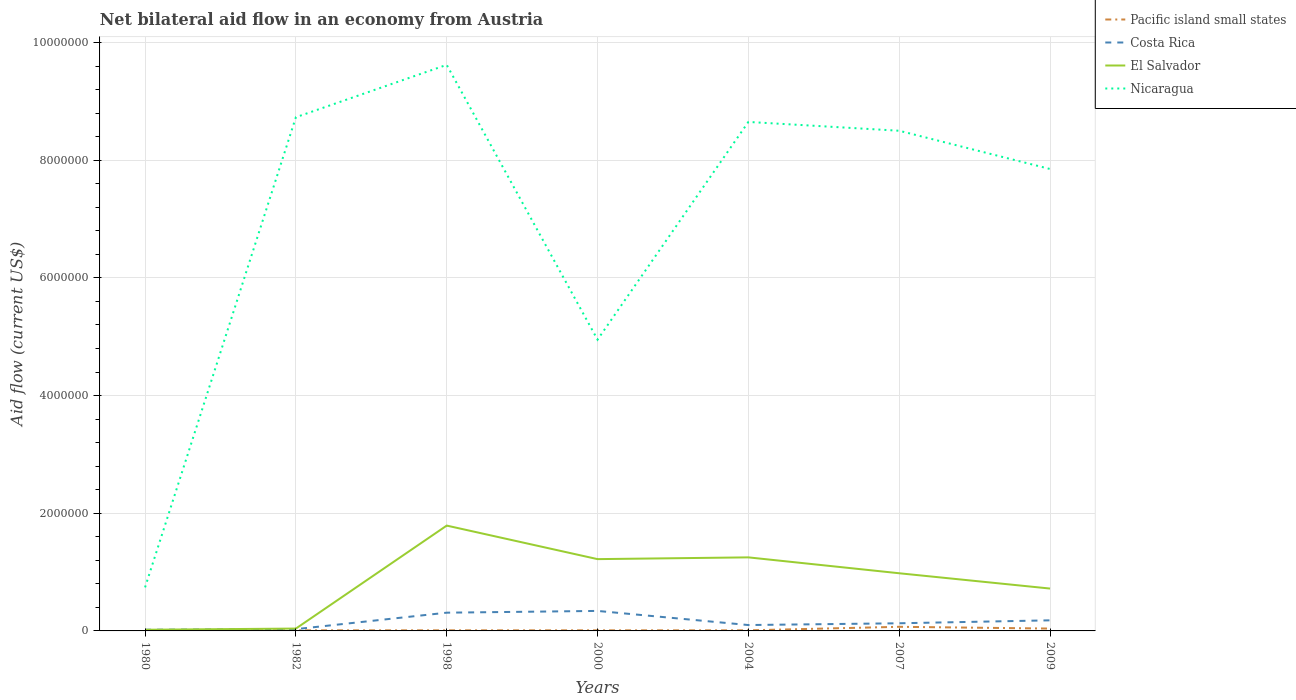Does the line corresponding to Nicaragua intersect with the line corresponding to El Salvador?
Offer a very short reply. No. Is the number of lines equal to the number of legend labels?
Ensure brevity in your answer.  Yes. What is the difference between the highest and the second highest net bilateral aid flow in Nicaragua?
Provide a short and direct response. 8.88e+06. How many lines are there?
Offer a terse response. 4. What is the difference between two consecutive major ticks on the Y-axis?
Your answer should be compact. 2.00e+06. Does the graph contain grids?
Keep it short and to the point. Yes. Where does the legend appear in the graph?
Provide a succinct answer. Top right. What is the title of the graph?
Your answer should be compact. Net bilateral aid flow in an economy from Austria. What is the label or title of the X-axis?
Offer a very short reply. Years. What is the label or title of the Y-axis?
Offer a very short reply. Aid flow (current US$). What is the Aid flow (current US$) in Pacific island small states in 1980?
Provide a short and direct response. 10000. What is the Aid flow (current US$) in Nicaragua in 1980?
Your answer should be very brief. 7.40e+05. What is the Aid flow (current US$) in Pacific island small states in 1982?
Keep it short and to the point. 10000. What is the Aid flow (current US$) of El Salvador in 1982?
Your answer should be compact. 4.00e+04. What is the Aid flow (current US$) of Nicaragua in 1982?
Provide a short and direct response. 8.73e+06. What is the Aid flow (current US$) in Costa Rica in 1998?
Give a very brief answer. 3.10e+05. What is the Aid flow (current US$) in El Salvador in 1998?
Offer a terse response. 1.79e+06. What is the Aid flow (current US$) of Nicaragua in 1998?
Give a very brief answer. 9.62e+06. What is the Aid flow (current US$) in Costa Rica in 2000?
Keep it short and to the point. 3.40e+05. What is the Aid flow (current US$) of El Salvador in 2000?
Give a very brief answer. 1.22e+06. What is the Aid flow (current US$) of Nicaragua in 2000?
Give a very brief answer. 4.95e+06. What is the Aid flow (current US$) in Pacific island small states in 2004?
Keep it short and to the point. 10000. What is the Aid flow (current US$) of El Salvador in 2004?
Your answer should be compact. 1.25e+06. What is the Aid flow (current US$) in Nicaragua in 2004?
Keep it short and to the point. 8.65e+06. What is the Aid flow (current US$) in El Salvador in 2007?
Provide a succinct answer. 9.80e+05. What is the Aid flow (current US$) in Nicaragua in 2007?
Make the answer very short. 8.50e+06. What is the Aid flow (current US$) of El Salvador in 2009?
Provide a succinct answer. 7.20e+05. What is the Aid flow (current US$) of Nicaragua in 2009?
Your response must be concise. 7.85e+06. Across all years, what is the maximum Aid flow (current US$) in El Salvador?
Offer a terse response. 1.79e+06. Across all years, what is the maximum Aid flow (current US$) of Nicaragua?
Your answer should be compact. 9.62e+06. Across all years, what is the minimum Aid flow (current US$) in Costa Rica?
Give a very brief answer. 2.00e+04. Across all years, what is the minimum Aid flow (current US$) of Nicaragua?
Ensure brevity in your answer.  7.40e+05. What is the total Aid flow (current US$) of Costa Rica in the graph?
Offer a very short reply. 1.11e+06. What is the total Aid flow (current US$) of El Salvador in the graph?
Your answer should be very brief. 6.02e+06. What is the total Aid flow (current US$) of Nicaragua in the graph?
Your answer should be compact. 4.90e+07. What is the difference between the Aid flow (current US$) in El Salvador in 1980 and that in 1982?
Your answer should be compact. -2.00e+04. What is the difference between the Aid flow (current US$) in Nicaragua in 1980 and that in 1982?
Your response must be concise. -7.99e+06. What is the difference between the Aid flow (current US$) of El Salvador in 1980 and that in 1998?
Offer a very short reply. -1.77e+06. What is the difference between the Aid flow (current US$) of Nicaragua in 1980 and that in 1998?
Your response must be concise. -8.88e+06. What is the difference between the Aid flow (current US$) in Pacific island small states in 1980 and that in 2000?
Your response must be concise. 0. What is the difference between the Aid flow (current US$) of Costa Rica in 1980 and that in 2000?
Provide a succinct answer. -3.20e+05. What is the difference between the Aid flow (current US$) in El Salvador in 1980 and that in 2000?
Ensure brevity in your answer.  -1.20e+06. What is the difference between the Aid flow (current US$) in Nicaragua in 1980 and that in 2000?
Ensure brevity in your answer.  -4.21e+06. What is the difference between the Aid flow (current US$) in Pacific island small states in 1980 and that in 2004?
Make the answer very short. 0. What is the difference between the Aid flow (current US$) in El Salvador in 1980 and that in 2004?
Provide a succinct answer. -1.23e+06. What is the difference between the Aid flow (current US$) in Nicaragua in 1980 and that in 2004?
Your answer should be very brief. -7.91e+06. What is the difference between the Aid flow (current US$) in El Salvador in 1980 and that in 2007?
Provide a succinct answer. -9.60e+05. What is the difference between the Aid flow (current US$) of Nicaragua in 1980 and that in 2007?
Your response must be concise. -7.76e+06. What is the difference between the Aid flow (current US$) of Pacific island small states in 1980 and that in 2009?
Keep it short and to the point. -3.00e+04. What is the difference between the Aid flow (current US$) of Costa Rica in 1980 and that in 2009?
Provide a short and direct response. -1.60e+05. What is the difference between the Aid flow (current US$) in El Salvador in 1980 and that in 2009?
Ensure brevity in your answer.  -7.00e+05. What is the difference between the Aid flow (current US$) in Nicaragua in 1980 and that in 2009?
Offer a terse response. -7.11e+06. What is the difference between the Aid flow (current US$) of Pacific island small states in 1982 and that in 1998?
Provide a succinct answer. 0. What is the difference between the Aid flow (current US$) of Costa Rica in 1982 and that in 1998?
Give a very brief answer. -2.80e+05. What is the difference between the Aid flow (current US$) of El Salvador in 1982 and that in 1998?
Offer a very short reply. -1.75e+06. What is the difference between the Aid flow (current US$) of Nicaragua in 1982 and that in 1998?
Provide a short and direct response. -8.90e+05. What is the difference between the Aid flow (current US$) of Pacific island small states in 1982 and that in 2000?
Your answer should be compact. 0. What is the difference between the Aid flow (current US$) of Costa Rica in 1982 and that in 2000?
Your answer should be compact. -3.10e+05. What is the difference between the Aid flow (current US$) in El Salvador in 1982 and that in 2000?
Provide a succinct answer. -1.18e+06. What is the difference between the Aid flow (current US$) in Nicaragua in 1982 and that in 2000?
Your answer should be very brief. 3.78e+06. What is the difference between the Aid flow (current US$) in Pacific island small states in 1982 and that in 2004?
Your answer should be very brief. 0. What is the difference between the Aid flow (current US$) in Costa Rica in 1982 and that in 2004?
Provide a succinct answer. -7.00e+04. What is the difference between the Aid flow (current US$) in El Salvador in 1982 and that in 2004?
Your answer should be compact. -1.21e+06. What is the difference between the Aid flow (current US$) in Nicaragua in 1982 and that in 2004?
Provide a succinct answer. 8.00e+04. What is the difference between the Aid flow (current US$) of El Salvador in 1982 and that in 2007?
Ensure brevity in your answer.  -9.40e+05. What is the difference between the Aid flow (current US$) in El Salvador in 1982 and that in 2009?
Offer a terse response. -6.80e+05. What is the difference between the Aid flow (current US$) in Nicaragua in 1982 and that in 2009?
Ensure brevity in your answer.  8.80e+05. What is the difference between the Aid flow (current US$) in Pacific island small states in 1998 and that in 2000?
Your response must be concise. 0. What is the difference between the Aid flow (current US$) in El Salvador in 1998 and that in 2000?
Your response must be concise. 5.70e+05. What is the difference between the Aid flow (current US$) of Nicaragua in 1998 and that in 2000?
Provide a succinct answer. 4.67e+06. What is the difference between the Aid flow (current US$) in Pacific island small states in 1998 and that in 2004?
Offer a terse response. 0. What is the difference between the Aid flow (current US$) of El Salvador in 1998 and that in 2004?
Offer a very short reply. 5.40e+05. What is the difference between the Aid flow (current US$) of Nicaragua in 1998 and that in 2004?
Your response must be concise. 9.70e+05. What is the difference between the Aid flow (current US$) of Costa Rica in 1998 and that in 2007?
Provide a short and direct response. 1.80e+05. What is the difference between the Aid flow (current US$) in El Salvador in 1998 and that in 2007?
Make the answer very short. 8.10e+05. What is the difference between the Aid flow (current US$) in Nicaragua in 1998 and that in 2007?
Provide a short and direct response. 1.12e+06. What is the difference between the Aid flow (current US$) in Pacific island small states in 1998 and that in 2009?
Your response must be concise. -3.00e+04. What is the difference between the Aid flow (current US$) in Costa Rica in 1998 and that in 2009?
Your response must be concise. 1.30e+05. What is the difference between the Aid flow (current US$) of El Salvador in 1998 and that in 2009?
Ensure brevity in your answer.  1.07e+06. What is the difference between the Aid flow (current US$) of Nicaragua in 1998 and that in 2009?
Ensure brevity in your answer.  1.77e+06. What is the difference between the Aid flow (current US$) of Costa Rica in 2000 and that in 2004?
Your answer should be very brief. 2.40e+05. What is the difference between the Aid flow (current US$) of Nicaragua in 2000 and that in 2004?
Make the answer very short. -3.70e+06. What is the difference between the Aid flow (current US$) in El Salvador in 2000 and that in 2007?
Offer a very short reply. 2.40e+05. What is the difference between the Aid flow (current US$) of Nicaragua in 2000 and that in 2007?
Provide a short and direct response. -3.55e+06. What is the difference between the Aid flow (current US$) in Pacific island small states in 2000 and that in 2009?
Your response must be concise. -3.00e+04. What is the difference between the Aid flow (current US$) in Costa Rica in 2000 and that in 2009?
Offer a terse response. 1.60e+05. What is the difference between the Aid flow (current US$) of El Salvador in 2000 and that in 2009?
Offer a very short reply. 5.00e+05. What is the difference between the Aid flow (current US$) of Nicaragua in 2000 and that in 2009?
Provide a succinct answer. -2.90e+06. What is the difference between the Aid flow (current US$) of Costa Rica in 2004 and that in 2007?
Offer a very short reply. -3.00e+04. What is the difference between the Aid flow (current US$) of Nicaragua in 2004 and that in 2007?
Your answer should be very brief. 1.50e+05. What is the difference between the Aid flow (current US$) in Costa Rica in 2004 and that in 2009?
Your answer should be very brief. -8.00e+04. What is the difference between the Aid flow (current US$) of El Salvador in 2004 and that in 2009?
Keep it short and to the point. 5.30e+05. What is the difference between the Aid flow (current US$) in Nicaragua in 2004 and that in 2009?
Give a very brief answer. 8.00e+05. What is the difference between the Aid flow (current US$) in Pacific island small states in 2007 and that in 2009?
Give a very brief answer. 3.00e+04. What is the difference between the Aid flow (current US$) in Nicaragua in 2007 and that in 2009?
Make the answer very short. 6.50e+05. What is the difference between the Aid flow (current US$) in Pacific island small states in 1980 and the Aid flow (current US$) in Costa Rica in 1982?
Keep it short and to the point. -2.00e+04. What is the difference between the Aid flow (current US$) of Pacific island small states in 1980 and the Aid flow (current US$) of El Salvador in 1982?
Offer a very short reply. -3.00e+04. What is the difference between the Aid flow (current US$) in Pacific island small states in 1980 and the Aid flow (current US$) in Nicaragua in 1982?
Keep it short and to the point. -8.72e+06. What is the difference between the Aid flow (current US$) of Costa Rica in 1980 and the Aid flow (current US$) of El Salvador in 1982?
Your answer should be compact. -2.00e+04. What is the difference between the Aid flow (current US$) of Costa Rica in 1980 and the Aid flow (current US$) of Nicaragua in 1982?
Ensure brevity in your answer.  -8.71e+06. What is the difference between the Aid flow (current US$) in El Salvador in 1980 and the Aid flow (current US$) in Nicaragua in 1982?
Provide a succinct answer. -8.71e+06. What is the difference between the Aid flow (current US$) in Pacific island small states in 1980 and the Aid flow (current US$) in Costa Rica in 1998?
Offer a terse response. -3.00e+05. What is the difference between the Aid flow (current US$) in Pacific island small states in 1980 and the Aid flow (current US$) in El Salvador in 1998?
Provide a succinct answer. -1.78e+06. What is the difference between the Aid flow (current US$) in Pacific island small states in 1980 and the Aid flow (current US$) in Nicaragua in 1998?
Your response must be concise. -9.61e+06. What is the difference between the Aid flow (current US$) in Costa Rica in 1980 and the Aid flow (current US$) in El Salvador in 1998?
Offer a very short reply. -1.77e+06. What is the difference between the Aid flow (current US$) of Costa Rica in 1980 and the Aid flow (current US$) of Nicaragua in 1998?
Keep it short and to the point. -9.60e+06. What is the difference between the Aid flow (current US$) of El Salvador in 1980 and the Aid flow (current US$) of Nicaragua in 1998?
Make the answer very short. -9.60e+06. What is the difference between the Aid flow (current US$) in Pacific island small states in 1980 and the Aid flow (current US$) in Costa Rica in 2000?
Make the answer very short. -3.30e+05. What is the difference between the Aid flow (current US$) of Pacific island small states in 1980 and the Aid flow (current US$) of El Salvador in 2000?
Make the answer very short. -1.21e+06. What is the difference between the Aid flow (current US$) in Pacific island small states in 1980 and the Aid flow (current US$) in Nicaragua in 2000?
Your response must be concise. -4.94e+06. What is the difference between the Aid flow (current US$) of Costa Rica in 1980 and the Aid flow (current US$) of El Salvador in 2000?
Keep it short and to the point. -1.20e+06. What is the difference between the Aid flow (current US$) in Costa Rica in 1980 and the Aid flow (current US$) in Nicaragua in 2000?
Your response must be concise. -4.93e+06. What is the difference between the Aid flow (current US$) of El Salvador in 1980 and the Aid flow (current US$) of Nicaragua in 2000?
Ensure brevity in your answer.  -4.93e+06. What is the difference between the Aid flow (current US$) of Pacific island small states in 1980 and the Aid flow (current US$) of El Salvador in 2004?
Keep it short and to the point. -1.24e+06. What is the difference between the Aid flow (current US$) of Pacific island small states in 1980 and the Aid flow (current US$) of Nicaragua in 2004?
Provide a short and direct response. -8.64e+06. What is the difference between the Aid flow (current US$) of Costa Rica in 1980 and the Aid flow (current US$) of El Salvador in 2004?
Make the answer very short. -1.23e+06. What is the difference between the Aid flow (current US$) of Costa Rica in 1980 and the Aid flow (current US$) of Nicaragua in 2004?
Ensure brevity in your answer.  -8.63e+06. What is the difference between the Aid flow (current US$) of El Salvador in 1980 and the Aid flow (current US$) of Nicaragua in 2004?
Ensure brevity in your answer.  -8.63e+06. What is the difference between the Aid flow (current US$) in Pacific island small states in 1980 and the Aid flow (current US$) in Costa Rica in 2007?
Keep it short and to the point. -1.20e+05. What is the difference between the Aid flow (current US$) of Pacific island small states in 1980 and the Aid flow (current US$) of El Salvador in 2007?
Make the answer very short. -9.70e+05. What is the difference between the Aid flow (current US$) in Pacific island small states in 1980 and the Aid flow (current US$) in Nicaragua in 2007?
Keep it short and to the point. -8.49e+06. What is the difference between the Aid flow (current US$) in Costa Rica in 1980 and the Aid flow (current US$) in El Salvador in 2007?
Give a very brief answer. -9.60e+05. What is the difference between the Aid flow (current US$) of Costa Rica in 1980 and the Aid flow (current US$) of Nicaragua in 2007?
Offer a very short reply. -8.48e+06. What is the difference between the Aid flow (current US$) of El Salvador in 1980 and the Aid flow (current US$) of Nicaragua in 2007?
Offer a terse response. -8.48e+06. What is the difference between the Aid flow (current US$) in Pacific island small states in 1980 and the Aid flow (current US$) in El Salvador in 2009?
Make the answer very short. -7.10e+05. What is the difference between the Aid flow (current US$) in Pacific island small states in 1980 and the Aid flow (current US$) in Nicaragua in 2009?
Offer a terse response. -7.84e+06. What is the difference between the Aid flow (current US$) in Costa Rica in 1980 and the Aid flow (current US$) in El Salvador in 2009?
Keep it short and to the point. -7.00e+05. What is the difference between the Aid flow (current US$) in Costa Rica in 1980 and the Aid flow (current US$) in Nicaragua in 2009?
Provide a succinct answer. -7.83e+06. What is the difference between the Aid flow (current US$) in El Salvador in 1980 and the Aid flow (current US$) in Nicaragua in 2009?
Offer a terse response. -7.83e+06. What is the difference between the Aid flow (current US$) of Pacific island small states in 1982 and the Aid flow (current US$) of Costa Rica in 1998?
Make the answer very short. -3.00e+05. What is the difference between the Aid flow (current US$) in Pacific island small states in 1982 and the Aid flow (current US$) in El Salvador in 1998?
Your answer should be very brief. -1.78e+06. What is the difference between the Aid flow (current US$) of Pacific island small states in 1982 and the Aid flow (current US$) of Nicaragua in 1998?
Your answer should be compact. -9.61e+06. What is the difference between the Aid flow (current US$) in Costa Rica in 1982 and the Aid flow (current US$) in El Salvador in 1998?
Ensure brevity in your answer.  -1.76e+06. What is the difference between the Aid flow (current US$) in Costa Rica in 1982 and the Aid flow (current US$) in Nicaragua in 1998?
Your response must be concise. -9.59e+06. What is the difference between the Aid flow (current US$) in El Salvador in 1982 and the Aid flow (current US$) in Nicaragua in 1998?
Offer a terse response. -9.58e+06. What is the difference between the Aid flow (current US$) of Pacific island small states in 1982 and the Aid flow (current US$) of Costa Rica in 2000?
Your answer should be very brief. -3.30e+05. What is the difference between the Aid flow (current US$) of Pacific island small states in 1982 and the Aid flow (current US$) of El Salvador in 2000?
Keep it short and to the point. -1.21e+06. What is the difference between the Aid flow (current US$) in Pacific island small states in 1982 and the Aid flow (current US$) in Nicaragua in 2000?
Your response must be concise. -4.94e+06. What is the difference between the Aid flow (current US$) of Costa Rica in 1982 and the Aid flow (current US$) of El Salvador in 2000?
Your response must be concise. -1.19e+06. What is the difference between the Aid flow (current US$) of Costa Rica in 1982 and the Aid flow (current US$) of Nicaragua in 2000?
Offer a terse response. -4.92e+06. What is the difference between the Aid flow (current US$) in El Salvador in 1982 and the Aid flow (current US$) in Nicaragua in 2000?
Make the answer very short. -4.91e+06. What is the difference between the Aid flow (current US$) of Pacific island small states in 1982 and the Aid flow (current US$) of El Salvador in 2004?
Offer a terse response. -1.24e+06. What is the difference between the Aid flow (current US$) in Pacific island small states in 1982 and the Aid flow (current US$) in Nicaragua in 2004?
Your answer should be very brief. -8.64e+06. What is the difference between the Aid flow (current US$) of Costa Rica in 1982 and the Aid flow (current US$) of El Salvador in 2004?
Offer a terse response. -1.22e+06. What is the difference between the Aid flow (current US$) in Costa Rica in 1982 and the Aid flow (current US$) in Nicaragua in 2004?
Provide a short and direct response. -8.62e+06. What is the difference between the Aid flow (current US$) of El Salvador in 1982 and the Aid flow (current US$) of Nicaragua in 2004?
Ensure brevity in your answer.  -8.61e+06. What is the difference between the Aid flow (current US$) of Pacific island small states in 1982 and the Aid flow (current US$) of El Salvador in 2007?
Your response must be concise. -9.70e+05. What is the difference between the Aid flow (current US$) in Pacific island small states in 1982 and the Aid flow (current US$) in Nicaragua in 2007?
Your response must be concise. -8.49e+06. What is the difference between the Aid flow (current US$) in Costa Rica in 1982 and the Aid flow (current US$) in El Salvador in 2007?
Offer a very short reply. -9.50e+05. What is the difference between the Aid flow (current US$) of Costa Rica in 1982 and the Aid flow (current US$) of Nicaragua in 2007?
Provide a short and direct response. -8.47e+06. What is the difference between the Aid flow (current US$) of El Salvador in 1982 and the Aid flow (current US$) of Nicaragua in 2007?
Your response must be concise. -8.46e+06. What is the difference between the Aid flow (current US$) in Pacific island small states in 1982 and the Aid flow (current US$) in Costa Rica in 2009?
Offer a very short reply. -1.70e+05. What is the difference between the Aid flow (current US$) in Pacific island small states in 1982 and the Aid flow (current US$) in El Salvador in 2009?
Provide a succinct answer. -7.10e+05. What is the difference between the Aid flow (current US$) of Pacific island small states in 1982 and the Aid flow (current US$) of Nicaragua in 2009?
Offer a very short reply. -7.84e+06. What is the difference between the Aid flow (current US$) in Costa Rica in 1982 and the Aid flow (current US$) in El Salvador in 2009?
Make the answer very short. -6.90e+05. What is the difference between the Aid flow (current US$) in Costa Rica in 1982 and the Aid flow (current US$) in Nicaragua in 2009?
Offer a terse response. -7.82e+06. What is the difference between the Aid flow (current US$) in El Salvador in 1982 and the Aid flow (current US$) in Nicaragua in 2009?
Give a very brief answer. -7.81e+06. What is the difference between the Aid flow (current US$) in Pacific island small states in 1998 and the Aid flow (current US$) in Costa Rica in 2000?
Provide a succinct answer. -3.30e+05. What is the difference between the Aid flow (current US$) in Pacific island small states in 1998 and the Aid flow (current US$) in El Salvador in 2000?
Give a very brief answer. -1.21e+06. What is the difference between the Aid flow (current US$) of Pacific island small states in 1998 and the Aid flow (current US$) of Nicaragua in 2000?
Ensure brevity in your answer.  -4.94e+06. What is the difference between the Aid flow (current US$) of Costa Rica in 1998 and the Aid flow (current US$) of El Salvador in 2000?
Provide a succinct answer. -9.10e+05. What is the difference between the Aid flow (current US$) of Costa Rica in 1998 and the Aid flow (current US$) of Nicaragua in 2000?
Provide a succinct answer. -4.64e+06. What is the difference between the Aid flow (current US$) in El Salvador in 1998 and the Aid flow (current US$) in Nicaragua in 2000?
Make the answer very short. -3.16e+06. What is the difference between the Aid flow (current US$) in Pacific island small states in 1998 and the Aid flow (current US$) in Costa Rica in 2004?
Your response must be concise. -9.00e+04. What is the difference between the Aid flow (current US$) in Pacific island small states in 1998 and the Aid flow (current US$) in El Salvador in 2004?
Ensure brevity in your answer.  -1.24e+06. What is the difference between the Aid flow (current US$) in Pacific island small states in 1998 and the Aid flow (current US$) in Nicaragua in 2004?
Offer a terse response. -8.64e+06. What is the difference between the Aid flow (current US$) of Costa Rica in 1998 and the Aid flow (current US$) of El Salvador in 2004?
Provide a short and direct response. -9.40e+05. What is the difference between the Aid flow (current US$) of Costa Rica in 1998 and the Aid flow (current US$) of Nicaragua in 2004?
Your response must be concise. -8.34e+06. What is the difference between the Aid flow (current US$) in El Salvador in 1998 and the Aid flow (current US$) in Nicaragua in 2004?
Keep it short and to the point. -6.86e+06. What is the difference between the Aid flow (current US$) of Pacific island small states in 1998 and the Aid flow (current US$) of El Salvador in 2007?
Your answer should be compact. -9.70e+05. What is the difference between the Aid flow (current US$) of Pacific island small states in 1998 and the Aid flow (current US$) of Nicaragua in 2007?
Provide a short and direct response. -8.49e+06. What is the difference between the Aid flow (current US$) in Costa Rica in 1998 and the Aid flow (current US$) in El Salvador in 2007?
Offer a terse response. -6.70e+05. What is the difference between the Aid flow (current US$) in Costa Rica in 1998 and the Aid flow (current US$) in Nicaragua in 2007?
Provide a succinct answer. -8.19e+06. What is the difference between the Aid flow (current US$) of El Salvador in 1998 and the Aid flow (current US$) of Nicaragua in 2007?
Your answer should be very brief. -6.71e+06. What is the difference between the Aid flow (current US$) of Pacific island small states in 1998 and the Aid flow (current US$) of Costa Rica in 2009?
Your response must be concise. -1.70e+05. What is the difference between the Aid flow (current US$) in Pacific island small states in 1998 and the Aid flow (current US$) in El Salvador in 2009?
Your response must be concise. -7.10e+05. What is the difference between the Aid flow (current US$) in Pacific island small states in 1998 and the Aid flow (current US$) in Nicaragua in 2009?
Provide a short and direct response. -7.84e+06. What is the difference between the Aid flow (current US$) of Costa Rica in 1998 and the Aid flow (current US$) of El Salvador in 2009?
Provide a succinct answer. -4.10e+05. What is the difference between the Aid flow (current US$) in Costa Rica in 1998 and the Aid flow (current US$) in Nicaragua in 2009?
Your answer should be very brief. -7.54e+06. What is the difference between the Aid flow (current US$) of El Salvador in 1998 and the Aid flow (current US$) of Nicaragua in 2009?
Provide a succinct answer. -6.06e+06. What is the difference between the Aid flow (current US$) of Pacific island small states in 2000 and the Aid flow (current US$) of El Salvador in 2004?
Give a very brief answer. -1.24e+06. What is the difference between the Aid flow (current US$) of Pacific island small states in 2000 and the Aid flow (current US$) of Nicaragua in 2004?
Your answer should be very brief. -8.64e+06. What is the difference between the Aid flow (current US$) in Costa Rica in 2000 and the Aid flow (current US$) in El Salvador in 2004?
Make the answer very short. -9.10e+05. What is the difference between the Aid flow (current US$) of Costa Rica in 2000 and the Aid flow (current US$) of Nicaragua in 2004?
Ensure brevity in your answer.  -8.31e+06. What is the difference between the Aid flow (current US$) in El Salvador in 2000 and the Aid flow (current US$) in Nicaragua in 2004?
Ensure brevity in your answer.  -7.43e+06. What is the difference between the Aid flow (current US$) in Pacific island small states in 2000 and the Aid flow (current US$) in El Salvador in 2007?
Make the answer very short. -9.70e+05. What is the difference between the Aid flow (current US$) in Pacific island small states in 2000 and the Aid flow (current US$) in Nicaragua in 2007?
Your answer should be compact. -8.49e+06. What is the difference between the Aid flow (current US$) of Costa Rica in 2000 and the Aid flow (current US$) of El Salvador in 2007?
Make the answer very short. -6.40e+05. What is the difference between the Aid flow (current US$) of Costa Rica in 2000 and the Aid flow (current US$) of Nicaragua in 2007?
Offer a terse response. -8.16e+06. What is the difference between the Aid flow (current US$) of El Salvador in 2000 and the Aid flow (current US$) of Nicaragua in 2007?
Ensure brevity in your answer.  -7.28e+06. What is the difference between the Aid flow (current US$) of Pacific island small states in 2000 and the Aid flow (current US$) of Costa Rica in 2009?
Give a very brief answer. -1.70e+05. What is the difference between the Aid flow (current US$) in Pacific island small states in 2000 and the Aid flow (current US$) in El Salvador in 2009?
Provide a short and direct response. -7.10e+05. What is the difference between the Aid flow (current US$) in Pacific island small states in 2000 and the Aid flow (current US$) in Nicaragua in 2009?
Give a very brief answer. -7.84e+06. What is the difference between the Aid flow (current US$) in Costa Rica in 2000 and the Aid flow (current US$) in El Salvador in 2009?
Your answer should be compact. -3.80e+05. What is the difference between the Aid flow (current US$) of Costa Rica in 2000 and the Aid flow (current US$) of Nicaragua in 2009?
Your answer should be compact. -7.51e+06. What is the difference between the Aid flow (current US$) in El Salvador in 2000 and the Aid flow (current US$) in Nicaragua in 2009?
Your answer should be compact. -6.63e+06. What is the difference between the Aid flow (current US$) of Pacific island small states in 2004 and the Aid flow (current US$) of Costa Rica in 2007?
Your response must be concise. -1.20e+05. What is the difference between the Aid flow (current US$) in Pacific island small states in 2004 and the Aid flow (current US$) in El Salvador in 2007?
Make the answer very short. -9.70e+05. What is the difference between the Aid flow (current US$) of Pacific island small states in 2004 and the Aid flow (current US$) of Nicaragua in 2007?
Provide a short and direct response. -8.49e+06. What is the difference between the Aid flow (current US$) in Costa Rica in 2004 and the Aid flow (current US$) in El Salvador in 2007?
Give a very brief answer. -8.80e+05. What is the difference between the Aid flow (current US$) in Costa Rica in 2004 and the Aid flow (current US$) in Nicaragua in 2007?
Keep it short and to the point. -8.40e+06. What is the difference between the Aid flow (current US$) of El Salvador in 2004 and the Aid flow (current US$) of Nicaragua in 2007?
Provide a succinct answer. -7.25e+06. What is the difference between the Aid flow (current US$) in Pacific island small states in 2004 and the Aid flow (current US$) in El Salvador in 2009?
Provide a succinct answer. -7.10e+05. What is the difference between the Aid flow (current US$) of Pacific island small states in 2004 and the Aid flow (current US$) of Nicaragua in 2009?
Provide a short and direct response. -7.84e+06. What is the difference between the Aid flow (current US$) of Costa Rica in 2004 and the Aid flow (current US$) of El Salvador in 2009?
Your answer should be very brief. -6.20e+05. What is the difference between the Aid flow (current US$) of Costa Rica in 2004 and the Aid flow (current US$) of Nicaragua in 2009?
Your answer should be very brief. -7.75e+06. What is the difference between the Aid flow (current US$) in El Salvador in 2004 and the Aid flow (current US$) in Nicaragua in 2009?
Provide a succinct answer. -6.60e+06. What is the difference between the Aid flow (current US$) of Pacific island small states in 2007 and the Aid flow (current US$) of El Salvador in 2009?
Offer a very short reply. -6.50e+05. What is the difference between the Aid flow (current US$) of Pacific island small states in 2007 and the Aid flow (current US$) of Nicaragua in 2009?
Offer a very short reply. -7.78e+06. What is the difference between the Aid flow (current US$) of Costa Rica in 2007 and the Aid flow (current US$) of El Salvador in 2009?
Ensure brevity in your answer.  -5.90e+05. What is the difference between the Aid flow (current US$) in Costa Rica in 2007 and the Aid flow (current US$) in Nicaragua in 2009?
Your answer should be compact. -7.72e+06. What is the difference between the Aid flow (current US$) of El Salvador in 2007 and the Aid flow (current US$) of Nicaragua in 2009?
Your answer should be very brief. -6.87e+06. What is the average Aid flow (current US$) of Pacific island small states per year?
Offer a very short reply. 2.29e+04. What is the average Aid flow (current US$) of Costa Rica per year?
Your response must be concise. 1.59e+05. What is the average Aid flow (current US$) of El Salvador per year?
Your answer should be compact. 8.60e+05. What is the average Aid flow (current US$) in Nicaragua per year?
Offer a terse response. 7.01e+06. In the year 1980, what is the difference between the Aid flow (current US$) of Pacific island small states and Aid flow (current US$) of El Salvador?
Give a very brief answer. -10000. In the year 1980, what is the difference between the Aid flow (current US$) of Pacific island small states and Aid flow (current US$) of Nicaragua?
Your answer should be compact. -7.30e+05. In the year 1980, what is the difference between the Aid flow (current US$) in Costa Rica and Aid flow (current US$) in El Salvador?
Make the answer very short. 0. In the year 1980, what is the difference between the Aid flow (current US$) of Costa Rica and Aid flow (current US$) of Nicaragua?
Provide a succinct answer. -7.20e+05. In the year 1980, what is the difference between the Aid flow (current US$) of El Salvador and Aid flow (current US$) of Nicaragua?
Provide a succinct answer. -7.20e+05. In the year 1982, what is the difference between the Aid flow (current US$) in Pacific island small states and Aid flow (current US$) in El Salvador?
Provide a short and direct response. -3.00e+04. In the year 1982, what is the difference between the Aid flow (current US$) of Pacific island small states and Aid flow (current US$) of Nicaragua?
Ensure brevity in your answer.  -8.72e+06. In the year 1982, what is the difference between the Aid flow (current US$) of Costa Rica and Aid flow (current US$) of Nicaragua?
Ensure brevity in your answer.  -8.70e+06. In the year 1982, what is the difference between the Aid flow (current US$) in El Salvador and Aid flow (current US$) in Nicaragua?
Your response must be concise. -8.69e+06. In the year 1998, what is the difference between the Aid flow (current US$) of Pacific island small states and Aid flow (current US$) of El Salvador?
Offer a terse response. -1.78e+06. In the year 1998, what is the difference between the Aid flow (current US$) of Pacific island small states and Aid flow (current US$) of Nicaragua?
Your response must be concise. -9.61e+06. In the year 1998, what is the difference between the Aid flow (current US$) of Costa Rica and Aid flow (current US$) of El Salvador?
Give a very brief answer. -1.48e+06. In the year 1998, what is the difference between the Aid flow (current US$) of Costa Rica and Aid flow (current US$) of Nicaragua?
Your answer should be very brief. -9.31e+06. In the year 1998, what is the difference between the Aid flow (current US$) of El Salvador and Aid flow (current US$) of Nicaragua?
Provide a short and direct response. -7.83e+06. In the year 2000, what is the difference between the Aid flow (current US$) in Pacific island small states and Aid flow (current US$) in Costa Rica?
Offer a very short reply. -3.30e+05. In the year 2000, what is the difference between the Aid flow (current US$) of Pacific island small states and Aid flow (current US$) of El Salvador?
Provide a succinct answer. -1.21e+06. In the year 2000, what is the difference between the Aid flow (current US$) of Pacific island small states and Aid flow (current US$) of Nicaragua?
Make the answer very short. -4.94e+06. In the year 2000, what is the difference between the Aid flow (current US$) of Costa Rica and Aid flow (current US$) of El Salvador?
Your answer should be very brief. -8.80e+05. In the year 2000, what is the difference between the Aid flow (current US$) in Costa Rica and Aid flow (current US$) in Nicaragua?
Give a very brief answer. -4.61e+06. In the year 2000, what is the difference between the Aid flow (current US$) in El Salvador and Aid flow (current US$) in Nicaragua?
Give a very brief answer. -3.73e+06. In the year 2004, what is the difference between the Aid flow (current US$) in Pacific island small states and Aid flow (current US$) in Costa Rica?
Give a very brief answer. -9.00e+04. In the year 2004, what is the difference between the Aid flow (current US$) in Pacific island small states and Aid flow (current US$) in El Salvador?
Provide a succinct answer. -1.24e+06. In the year 2004, what is the difference between the Aid flow (current US$) of Pacific island small states and Aid flow (current US$) of Nicaragua?
Provide a succinct answer. -8.64e+06. In the year 2004, what is the difference between the Aid flow (current US$) in Costa Rica and Aid flow (current US$) in El Salvador?
Ensure brevity in your answer.  -1.15e+06. In the year 2004, what is the difference between the Aid flow (current US$) of Costa Rica and Aid flow (current US$) of Nicaragua?
Keep it short and to the point. -8.55e+06. In the year 2004, what is the difference between the Aid flow (current US$) in El Salvador and Aid flow (current US$) in Nicaragua?
Provide a succinct answer. -7.40e+06. In the year 2007, what is the difference between the Aid flow (current US$) in Pacific island small states and Aid flow (current US$) in Costa Rica?
Give a very brief answer. -6.00e+04. In the year 2007, what is the difference between the Aid flow (current US$) in Pacific island small states and Aid flow (current US$) in El Salvador?
Offer a terse response. -9.10e+05. In the year 2007, what is the difference between the Aid flow (current US$) in Pacific island small states and Aid flow (current US$) in Nicaragua?
Offer a terse response. -8.43e+06. In the year 2007, what is the difference between the Aid flow (current US$) in Costa Rica and Aid flow (current US$) in El Salvador?
Your answer should be very brief. -8.50e+05. In the year 2007, what is the difference between the Aid flow (current US$) in Costa Rica and Aid flow (current US$) in Nicaragua?
Offer a terse response. -8.37e+06. In the year 2007, what is the difference between the Aid flow (current US$) in El Salvador and Aid flow (current US$) in Nicaragua?
Offer a very short reply. -7.52e+06. In the year 2009, what is the difference between the Aid flow (current US$) of Pacific island small states and Aid flow (current US$) of El Salvador?
Offer a very short reply. -6.80e+05. In the year 2009, what is the difference between the Aid flow (current US$) of Pacific island small states and Aid flow (current US$) of Nicaragua?
Keep it short and to the point. -7.81e+06. In the year 2009, what is the difference between the Aid flow (current US$) in Costa Rica and Aid flow (current US$) in El Salvador?
Ensure brevity in your answer.  -5.40e+05. In the year 2009, what is the difference between the Aid flow (current US$) of Costa Rica and Aid flow (current US$) of Nicaragua?
Make the answer very short. -7.67e+06. In the year 2009, what is the difference between the Aid flow (current US$) in El Salvador and Aid flow (current US$) in Nicaragua?
Give a very brief answer. -7.13e+06. What is the ratio of the Aid flow (current US$) in Costa Rica in 1980 to that in 1982?
Give a very brief answer. 0.67. What is the ratio of the Aid flow (current US$) in Nicaragua in 1980 to that in 1982?
Make the answer very short. 0.08. What is the ratio of the Aid flow (current US$) of Pacific island small states in 1980 to that in 1998?
Keep it short and to the point. 1. What is the ratio of the Aid flow (current US$) in Costa Rica in 1980 to that in 1998?
Offer a very short reply. 0.06. What is the ratio of the Aid flow (current US$) of El Salvador in 1980 to that in 1998?
Ensure brevity in your answer.  0.01. What is the ratio of the Aid flow (current US$) in Nicaragua in 1980 to that in 1998?
Ensure brevity in your answer.  0.08. What is the ratio of the Aid flow (current US$) in Pacific island small states in 1980 to that in 2000?
Give a very brief answer. 1. What is the ratio of the Aid flow (current US$) in Costa Rica in 1980 to that in 2000?
Make the answer very short. 0.06. What is the ratio of the Aid flow (current US$) of El Salvador in 1980 to that in 2000?
Offer a terse response. 0.02. What is the ratio of the Aid flow (current US$) of Nicaragua in 1980 to that in 2000?
Your answer should be compact. 0.15. What is the ratio of the Aid flow (current US$) of El Salvador in 1980 to that in 2004?
Make the answer very short. 0.02. What is the ratio of the Aid flow (current US$) of Nicaragua in 1980 to that in 2004?
Provide a short and direct response. 0.09. What is the ratio of the Aid flow (current US$) in Pacific island small states in 1980 to that in 2007?
Offer a very short reply. 0.14. What is the ratio of the Aid flow (current US$) in Costa Rica in 1980 to that in 2007?
Your answer should be compact. 0.15. What is the ratio of the Aid flow (current US$) in El Salvador in 1980 to that in 2007?
Your response must be concise. 0.02. What is the ratio of the Aid flow (current US$) of Nicaragua in 1980 to that in 2007?
Provide a short and direct response. 0.09. What is the ratio of the Aid flow (current US$) of El Salvador in 1980 to that in 2009?
Your answer should be very brief. 0.03. What is the ratio of the Aid flow (current US$) of Nicaragua in 1980 to that in 2009?
Give a very brief answer. 0.09. What is the ratio of the Aid flow (current US$) in Costa Rica in 1982 to that in 1998?
Provide a succinct answer. 0.1. What is the ratio of the Aid flow (current US$) in El Salvador in 1982 to that in 1998?
Make the answer very short. 0.02. What is the ratio of the Aid flow (current US$) in Nicaragua in 1982 to that in 1998?
Your response must be concise. 0.91. What is the ratio of the Aid flow (current US$) of Costa Rica in 1982 to that in 2000?
Ensure brevity in your answer.  0.09. What is the ratio of the Aid flow (current US$) of El Salvador in 1982 to that in 2000?
Your response must be concise. 0.03. What is the ratio of the Aid flow (current US$) of Nicaragua in 1982 to that in 2000?
Provide a succinct answer. 1.76. What is the ratio of the Aid flow (current US$) of Pacific island small states in 1982 to that in 2004?
Offer a very short reply. 1. What is the ratio of the Aid flow (current US$) in El Salvador in 1982 to that in 2004?
Your response must be concise. 0.03. What is the ratio of the Aid flow (current US$) in Nicaragua in 1982 to that in 2004?
Ensure brevity in your answer.  1.01. What is the ratio of the Aid flow (current US$) of Pacific island small states in 1982 to that in 2007?
Your response must be concise. 0.14. What is the ratio of the Aid flow (current US$) in Costa Rica in 1982 to that in 2007?
Your response must be concise. 0.23. What is the ratio of the Aid flow (current US$) in El Salvador in 1982 to that in 2007?
Provide a succinct answer. 0.04. What is the ratio of the Aid flow (current US$) of Nicaragua in 1982 to that in 2007?
Keep it short and to the point. 1.03. What is the ratio of the Aid flow (current US$) of Costa Rica in 1982 to that in 2009?
Your answer should be very brief. 0.17. What is the ratio of the Aid flow (current US$) of El Salvador in 1982 to that in 2009?
Your response must be concise. 0.06. What is the ratio of the Aid flow (current US$) in Nicaragua in 1982 to that in 2009?
Your answer should be compact. 1.11. What is the ratio of the Aid flow (current US$) in Pacific island small states in 1998 to that in 2000?
Give a very brief answer. 1. What is the ratio of the Aid flow (current US$) in Costa Rica in 1998 to that in 2000?
Keep it short and to the point. 0.91. What is the ratio of the Aid flow (current US$) in El Salvador in 1998 to that in 2000?
Your answer should be very brief. 1.47. What is the ratio of the Aid flow (current US$) of Nicaragua in 1998 to that in 2000?
Offer a very short reply. 1.94. What is the ratio of the Aid flow (current US$) in Costa Rica in 1998 to that in 2004?
Provide a succinct answer. 3.1. What is the ratio of the Aid flow (current US$) of El Salvador in 1998 to that in 2004?
Your response must be concise. 1.43. What is the ratio of the Aid flow (current US$) of Nicaragua in 1998 to that in 2004?
Ensure brevity in your answer.  1.11. What is the ratio of the Aid flow (current US$) of Pacific island small states in 1998 to that in 2007?
Keep it short and to the point. 0.14. What is the ratio of the Aid flow (current US$) of Costa Rica in 1998 to that in 2007?
Make the answer very short. 2.38. What is the ratio of the Aid flow (current US$) in El Salvador in 1998 to that in 2007?
Offer a terse response. 1.83. What is the ratio of the Aid flow (current US$) of Nicaragua in 1998 to that in 2007?
Offer a very short reply. 1.13. What is the ratio of the Aid flow (current US$) of Costa Rica in 1998 to that in 2009?
Your response must be concise. 1.72. What is the ratio of the Aid flow (current US$) of El Salvador in 1998 to that in 2009?
Ensure brevity in your answer.  2.49. What is the ratio of the Aid flow (current US$) of Nicaragua in 1998 to that in 2009?
Offer a very short reply. 1.23. What is the ratio of the Aid flow (current US$) in Costa Rica in 2000 to that in 2004?
Your answer should be compact. 3.4. What is the ratio of the Aid flow (current US$) in El Salvador in 2000 to that in 2004?
Ensure brevity in your answer.  0.98. What is the ratio of the Aid flow (current US$) in Nicaragua in 2000 to that in 2004?
Provide a succinct answer. 0.57. What is the ratio of the Aid flow (current US$) of Pacific island small states in 2000 to that in 2007?
Offer a terse response. 0.14. What is the ratio of the Aid flow (current US$) of Costa Rica in 2000 to that in 2007?
Provide a short and direct response. 2.62. What is the ratio of the Aid flow (current US$) of El Salvador in 2000 to that in 2007?
Your answer should be compact. 1.24. What is the ratio of the Aid flow (current US$) of Nicaragua in 2000 to that in 2007?
Your response must be concise. 0.58. What is the ratio of the Aid flow (current US$) of Pacific island small states in 2000 to that in 2009?
Keep it short and to the point. 0.25. What is the ratio of the Aid flow (current US$) in Costa Rica in 2000 to that in 2009?
Offer a terse response. 1.89. What is the ratio of the Aid flow (current US$) in El Salvador in 2000 to that in 2009?
Give a very brief answer. 1.69. What is the ratio of the Aid flow (current US$) of Nicaragua in 2000 to that in 2009?
Your answer should be very brief. 0.63. What is the ratio of the Aid flow (current US$) of Pacific island small states in 2004 to that in 2007?
Make the answer very short. 0.14. What is the ratio of the Aid flow (current US$) of Costa Rica in 2004 to that in 2007?
Keep it short and to the point. 0.77. What is the ratio of the Aid flow (current US$) of El Salvador in 2004 to that in 2007?
Offer a terse response. 1.28. What is the ratio of the Aid flow (current US$) of Nicaragua in 2004 to that in 2007?
Your response must be concise. 1.02. What is the ratio of the Aid flow (current US$) in Costa Rica in 2004 to that in 2009?
Your response must be concise. 0.56. What is the ratio of the Aid flow (current US$) in El Salvador in 2004 to that in 2009?
Your answer should be very brief. 1.74. What is the ratio of the Aid flow (current US$) in Nicaragua in 2004 to that in 2009?
Your response must be concise. 1.1. What is the ratio of the Aid flow (current US$) of Pacific island small states in 2007 to that in 2009?
Provide a short and direct response. 1.75. What is the ratio of the Aid flow (current US$) of Costa Rica in 2007 to that in 2009?
Ensure brevity in your answer.  0.72. What is the ratio of the Aid flow (current US$) of El Salvador in 2007 to that in 2009?
Provide a short and direct response. 1.36. What is the ratio of the Aid flow (current US$) in Nicaragua in 2007 to that in 2009?
Give a very brief answer. 1.08. What is the difference between the highest and the second highest Aid flow (current US$) in Pacific island small states?
Your response must be concise. 3.00e+04. What is the difference between the highest and the second highest Aid flow (current US$) in El Salvador?
Ensure brevity in your answer.  5.40e+05. What is the difference between the highest and the second highest Aid flow (current US$) in Nicaragua?
Give a very brief answer. 8.90e+05. What is the difference between the highest and the lowest Aid flow (current US$) in Pacific island small states?
Your response must be concise. 6.00e+04. What is the difference between the highest and the lowest Aid flow (current US$) of El Salvador?
Provide a short and direct response. 1.77e+06. What is the difference between the highest and the lowest Aid flow (current US$) in Nicaragua?
Provide a succinct answer. 8.88e+06. 